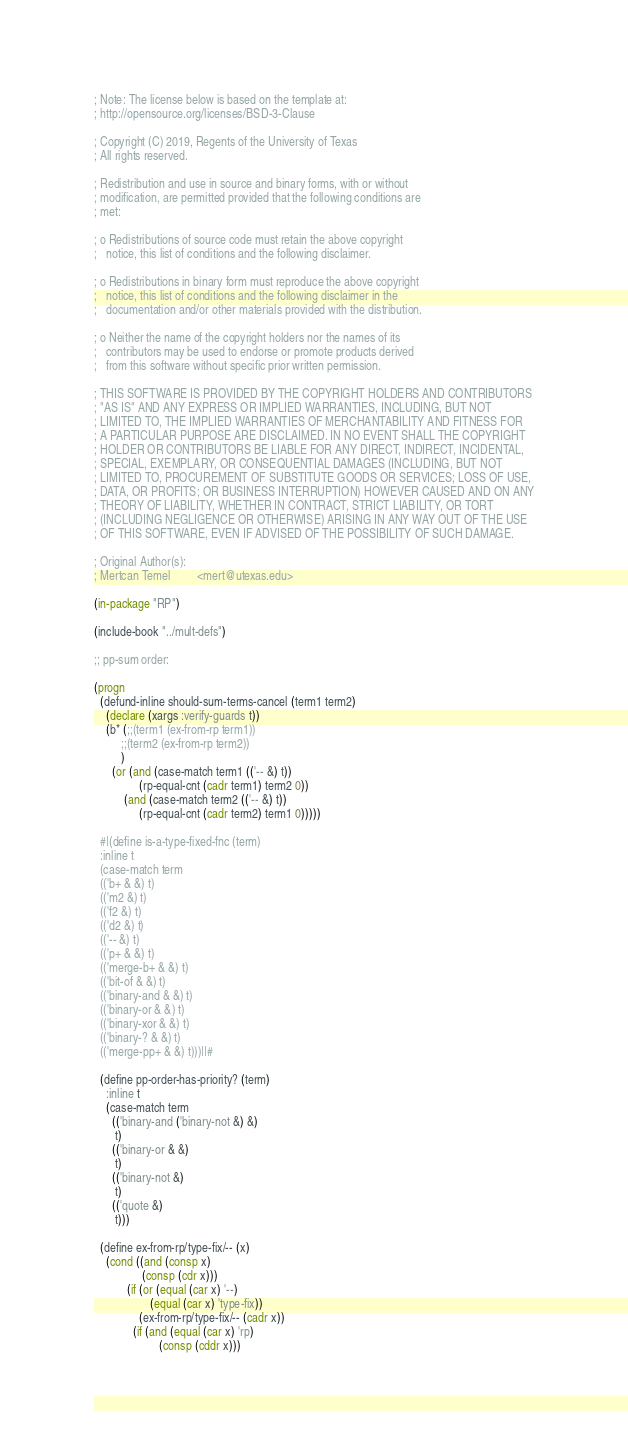<code> <loc_0><loc_0><loc_500><loc_500><_Lisp_>; Note: The license below is based on the template at:
; http://opensource.org/licenses/BSD-3-Clause

; Copyright (C) 2019, Regents of the University of Texas
; All rights reserved.

; Redistribution and use in source and binary forms, with or without
; modification, are permitted provided that the following conditions are
; met:

; o Redistributions of source code must retain the above copyright
;   notice, this list of conditions and the following disclaimer.

; o Redistributions in binary form must reproduce the above copyright
;   notice, this list of conditions and the following disclaimer in the
;   documentation and/or other materials provided with the distribution.

; o Neither the name of the copyright holders nor the names of its
;   contributors may be used to endorse or promote products derived
;   from this software without specific prior written permission.

; THIS SOFTWARE IS PROVIDED BY THE COPYRIGHT HOLDERS AND CONTRIBUTORS
; "AS IS" AND ANY EXPRESS OR IMPLIED WARRANTIES, INCLUDING, BUT NOT
; LIMITED TO, THE IMPLIED WARRANTIES OF MERCHANTABILITY AND FITNESS FOR
; A PARTICULAR PURPOSE ARE DISCLAIMED. IN NO EVENT SHALL THE COPYRIGHT
; HOLDER OR CONTRIBUTORS BE LIABLE FOR ANY DIRECT, INDIRECT, INCIDENTAL,
; SPECIAL, EXEMPLARY, OR CONSEQUENTIAL DAMAGES (INCLUDING, BUT NOT
; LIMITED TO, PROCUREMENT OF SUBSTITUTE GOODS OR SERVICES; LOSS OF USE,
; DATA, OR PROFITS; OR BUSINESS INTERRUPTION) HOWEVER CAUSED AND ON ANY
; THEORY OF LIABILITY, WHETHER IN CONTRACT, STRICT LIABILITY, OR TORT
; (INCLUDING NEGLIGENCE OR OTHERWISE) ARISING IN ANY WAY OUT OF THE USE
; OF THIS SOFTWARE, EVEN IF ADVISED OF THE POSSIBILITY OF SUCH DAMAGE.

; Original Author(s):
; Mertcan Temel         <mert@utexas.edu>

(in-package "RP")

(include-book "../mult-defs")

;; pp-sum order:

(progn
  (defund-inline should-sum-terms-cancel (term1 term2)
    (declare (xargs :verify-guards t))
    (b* (;;(term1 (ex-from-rp term1))
         ;;(term2 (ex-from-rp term2))
         )
      (or (and (case-match term1 (('-- &) t))
               (rp-equal-cnt (cadr term1) term2 0))
          (and (case-match term2 (('-- &) t))
               (rp-equal-cnt (cadr term2) term1 0)))))

  #|(define is-a-type-fixed-fnc (term)
  :inline t
  (case-match term
  (('b+ & &) t)
  (('m2 &) t)
  (('f2 &) t)
  (('d2 &) t)
  (('-- &) t)
  (('p+ & &) t)
  (('merge-b+ & &) t)
  (('bit-of & &) t)
  (('binary-and & &) t)
  (('binary-or & &) t)
  (('binary-xor & &) t)
  (('binary-? & &) t)
  (('merge-pp+ & &) t)))||#

  (define pp-order-has-priority? (term)
    :inline t
    (case-match term
      (('binary-and ('binary-not &) &)
       t)
      (('binary-or & &)
       t)
      (('binary-not &)
       t)
      (('quote &)
       t)))

  (define ex-from-rp/type-fix/-- (x)
    (cond ((and (consp x)
                (consp (cdr x)))
           (if (or (equal (car x) '--)
                   (equal (car x) 'type-fix))
               (ex-from-rp/type-fix/-- (cadr x))
             (if (and (equal (car x) 'rp)
                      (consp (cddr x)))</code> 